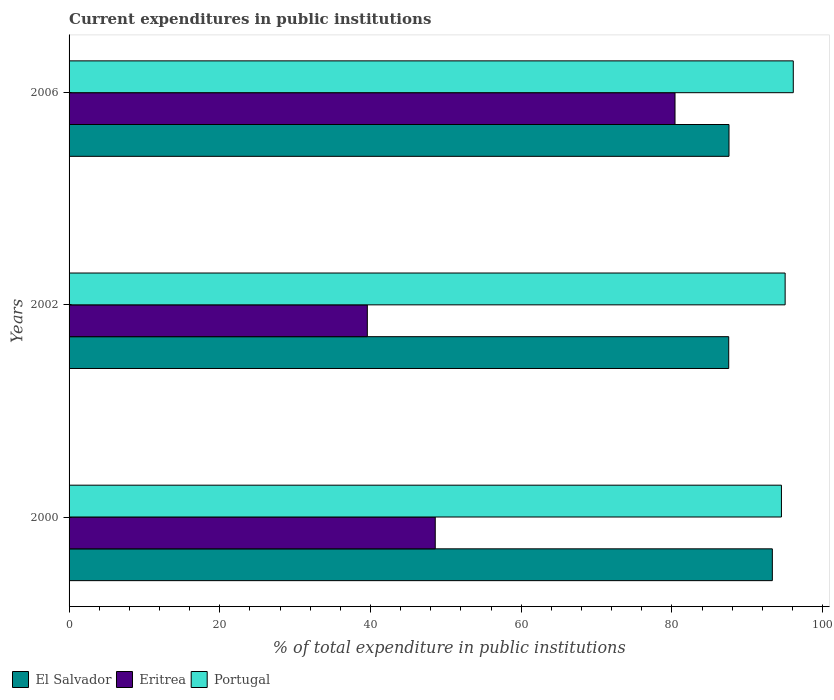How many different coloured bars are there?
Offer a terse response. 3. How many groups of bars are there?
Your answer should be very brief. 3. Are the number of bars per tick equal to the number of legend labels?
Offer a very short reply. Yes. How many bars are there on the 1st tick from the top?
Ensure brevity in your answer.  3. How many bars are there on the 1st tick from the bottom?
Your answer should be compact. 3. In how many cases, is the number of bars for a given year not equal to the number of legend labels?
Provide a succinct answer. 0. What is the current expenditures in public institutions in Eritrea in 2000?
Give a very brief answer. 48.59. Across all years, what is the maximum current expenditures in public institutions in El Salvador?
Your response must be concise. 93.33. Across all years, what is the minimum current expenditures in public institutions in El Salvador?
Offer a terse response. 87.54. In which year was the current expenditures in public institutions in El Salvador minimum?
Provide a short and direct response. 2002. What is the total current expenditures in public institutions in Eritrea in the graph?
Your answer should be compact. 168.59. What is the difference between the current expenditures in public institutions in Portugal in 2000 and that in 2006?
Provide a succinct answer. -1.57. What is the difference between the current expenditures in public institutions in Portugal in 2006 and the current expenditures in public institutions in El Salvador in 2000?
Give a very brief answer. 2.78. What is the average current expenditures in public institutions in Portugal per year?
Provide a short and direct response. 95.22. In the year 2002, what is the difference between the current expenditures in public institutions in Eritrea and current expenditures in public institutions in Portugal?
Provide a short and direct response. -55.45. What is the ratio of the current expenditures in public institutions in El Salvador in 2000 to that in 2006?
Ensure brevity in your answer.  1.07. Is the current expenditures in public institutions in El Salvador in 2000 less than that in 2006?
Give a very brief answer. No. Is the difference between the current expenditures in public institutions in Eritrea in 2002 and 2006 greater than the difference between the current expenditures in public institutions in Portugal in 2002 and 2006?
Your answer should be very brief. No. What is the difference between the highest and the second highest current expenditures in public institutions in El Salvador?
Provide a short and direct response. 5.75. What is the difference between the highest and the lowest current expenditures in public institutions in Portugal?
Make the answer very short. 1.57. In how many years, is the current expenditures in public institutions in Eritrea greater than the average current expenditures in public institutions in Eritrea taken over all years?
Keep it short and to the point. 1. Is the sum of the current expenditures in public institutions in Eritrea in 2000 and 2002 greater than the maximum current expenditures in public institutions in Portugal across all years?
Your response must be concise. No. What does the 2nd bar from the bottom in 2000 represents?
Provide a short and direct response. Eritrea. Is it the case that in every year, the sum of the current expenditures in public institutions in El Salvador and current expenditures in public institutions in Portugal is greater than the current expenditures in public institutions in Eritrea?
Give a very brief answer. Yes. Are all the bars in the graph horizontal?
Your answer should be compact. Yes. Does the graph contain any zero values?
Keep it short and to the point. No. Does the graph contain grids?
Offer a terse response. No. Where does the legend appear in the graph?
Offer a very short reply. Bottom left. How are the legend labels stacked?
Your answer should be compact. Horizontal. What is the title of the graph?
Keep it short and to the point. Current expenditures in public institutions. What is the label or title of the X-axis?
Offer a very short reply. % of total expenditure in public institutions. What is the label or title of the Y-axis?
Ensure brevity in your answer.  Years. What is the % of total expenditure in public institutions of El Salvador in 2000?
Provide a short and direct response. 93.33. What is the % of total expenditure in public institutions in Eritrea in 2000?
Provide a short and direct response. 48.59. What is the % of total expenditure in public institutions of Portugal in 2000?
Provide a succinct answer. 94.54. What is the % of total expenditure in public institutions in El Salvador in 2002?
Offer a terse response. 87.54. What is the % of total expenditure in public institutions in Eritrea in 2002?
Your answer should be compact. 39.58. What is the % of total expenditure in public institutions in Portugal in 2002?
Provide a short and direct response. 95.03. What is the % of total expenditure in public institutions in El Salvador in 2006?
Give a very brief answer. 87.58. What is the % of total expenditure in public institutions in Eritrea in 2006?
Provide a succinct answer. 80.41. What is the % of total expenditure in public institutions of Portugal in 2006?
Your response must be concise. 96.11. Across all years, what is the maximum % of total expenditure in public institutions of El Salvador?
Provide a succinct answer. 93.33. Across all years, what is the maximum % of total expenditure in public institutions in Eritrea?
Your answer should be compact. 80.41. Across all years, what is the maximum % of total expenditure in public institutions of Portugal?
Your answer should be compact. 96.11. Across all years, what is the minimum % of total expenditure in public institutions in El Salvador?
Give a very brief answer. 87.54. Across all years, what is the minimum % of total expenditure in public institutions of Eritrea?
Ensure brevity in your answer.  39.58. Across all years, what is the minimum % of total expenditure in public institutions of Portugal?
Offer a terse response. 94.54. What is the total % of total expenditure in public institutions of El Salvador in the graph?
Your answer should be compact. 268.45. What is the total % of total expenditure in public institutions in Eritrea in the graph?
Ensure brevity in your answer.  168.59. What is the total % of total expenditure in public institutions of Portugal in the graph?
Give a very brief answer. 285.67. What is the difference between the % of total expenditure in public institutions in El Salvador in 2000 and that in 2002?
Make the answer very short. 5.79. What is the difference between the % of total expenditure in public institutions in Eritrea in 2000 and that in 2002?
Your response must be concise. 9.01. What is the difference between the % of total expenditure in public institutions in Portugal in 2000 and that in 2002?
Give a very brief answer. -0.49. What is the difference between the % of total expenditure in public institutions in El Salvador in 2000 and that in 2006?
Provide a succinct answer. 5.75. What is the difference between the % of total expenditure in public institutions in Eritrea in 2000 and that in 2006?
Ensure brevity in your answer.  -31.82. What is the difference between the % of total expenditure in public institutions in Portugal in 2000 and that in 2006?
Provide a short and direct response. -1.57. What is the difference between the % of total expenditure in public institutions of El Salvador in 2002 and that in 2006?
Give a very brief answer. -0.04. What is the difference between the % of total expenditure in public institutions in Eritrea in 2002 and that in 2006?
Offer a terse response. -40.83. What is the difference between the % of total expenditure in public institutions in Portugal in 2002 and that in 2006?
Give a very brief answer. -1.08. What is the difference between the % of total expenditure in public institutions of El Salvador in 2000 and the % of total expenditure in public institutions of Eritrea in 2002?
Your response must be concise. 53.75. What is the difference between the % of total expenditure in public institutions of El Salvador in 2000 and the % of total expenditure in public institutions of Portugal in 2002?
Make the answer very short. -1.7. What is the difference between the % of total expenditure in public institutions of Eritrea in 2000 and the % of total expenditure in public institutions of Portugal in 2002?
Your answer should be very brief. -46.43. What is the difference between the % of total expenditure in public institutions of El Salvador in 2000 and the % of total expenditure in public institutions of Eritrea in 2006?
Offer a terse response. 12.92. What is the difference between the % of total expenditure in public institutions in El Salvador in 2000 and the % of total expenditure in public institutions in Portugal in 2006?
Ensure brevity in your answer.  -2.78. What is the difference between the % of total expenditure in public institutions in Eritrea in 2000 and the % of total expenditure in public institutions in Portugal in 2006?
Provide a succinct answer. -47.51. What is the difference between the % of total expenditure in public institutions of El Salvador in 2002 and the % of total expenditure in public institutions of Eritrea in 2006?
Your answer should be very brief. 7.13. What is the difference between the % of total expenditure in public institutions of El Salvador in 2002 and the % of total expenditure in public institutions of Portugal in 2006?
Your response must be concise. -8.57. What is the difference between the % of total expenditure in public institutions in Eritrea in 2002 and the % of total expenditure in public institutions in Portugal in 2006?
Provide a succinct answer. -56.53. What is the average % of total expenditure in public institutions in El Salvador per year?
Ensure brevity in your answer.  89.48. What is the average % of total expenditure in public institutions of Eritrea per year?
Your answer should be compact. 56.2. What is the average % of total expenditure in public institutions in Portugal per year?
Keep it short and to the point. 95.22. In the year 2000, what is the difference between the % of total expenditure in public institutions of El Salvador and % of total expenditure in public institutions of Eritrea?
Keep it short and to the point. 44.74. In the year 2000, what is the difference between the % of total expenditure in public institutions in El Salvador and % of total expenditure in public institutions in Portugal?
Your response must be concise. -1.21. In the year 2000, what is the difference between the % of total expenditure in public institutions in Eritrea and % of total expenditure in public institutions in Portugal?
Your answer should be very brief. -45.94. In the year 2002, what is the difference between the % of total expenditure in public institutions of El Salvador and % of total expenditure in public institutions of Eritrea?
Give a very brief answer. 47.96. In the year 2002, what is the difference between the % of total expenditure in public institutions in El Salvador and % of total expenditure in public institutions in Portugal?
Make the answer very short. -7.49. In the year 2002, what is the difference between the % of total expenditure in public institutions of Eritrea and % of total expenditure in public institutions of Portugal?
Provide a short and direct response. -55.45. In the year 2006, what is the difference between the % of total expenditure in public institutions of El Salvador and % of total expenditure in public institutions of Eritrea?
Provide a succinct answer. 7.16. In the year 2006, what is the difference between the % of total expenditure in public institutions in El Salvador and % of total expenditure in public institutions in Portugal?
Ensure brevity in your answer.  -8.53. In the year 2006, what is the difference between the % of total expenditure in public institutions of Eritrea and % of total expenditure in public institutions of Portugal?
Provide a short and direct response. -15.7. What is the ratio of the % of total expenditure in public institutions in El Salvador in 2000 to that in 2002?
Make the answer very short. 1.07. What is the ratio of the % of total expenditure in public institutions of Eritrea in 2000 to that in 2002?
Your answer should be compact. 1.23. What is the ratio of the % of total expenditure in public institutions of El Salvador in 2000 to that in 2006?
Your answer should be compact. 1.07. What is the ratio of the % of total expenditure in public institutions in Eritrea in 2000 to that in 2006?
Provide a short and direct response. 0.6. What is the ratio of the % of total expenditure in public institutions of Portugal in 2000 to that in 2006?
Your answer should be compact. 0.98. What is the ratio of the % of total expenditure in public institutions in El Salvador in 2002 to that in 2006?
Offer a very short reply. 1. What is the ratio of the % of total expenditure in public institutions of Eritrea in 2002 to that in 2006?
Offer a terse response. 0.49. What is the ratio of the % of total expenditure in public institutions in Portugal in 2002 to that in 2006?
Offer a very short reply. 0.99. What is the difference between the highest and the second highest % of total expenditure in public institutions of El Salvador?
Your answer should be very brief. 5.75. What is the difference between the highest and the second highest % of total expenditure in public institutions of Eritrea?
Your answer should be compact. 31.82. What is the difference between the highest and the second highest % of total expenditure in public institutions of Portugal?
Make the answer very short. 1.08. What is the difference between the highest and the lowest % of total expenditure in public institutions of El Salvador?
Your answer should be very brief. 5.79. What is the difference between the highest and the lowest % of total expenditure in public institutions in Eritrea?
Ensure brevity in your answer.  40.83. What is the difference between the highest and the lowest % of total expenditure in public institutions in Portugal?
Provide a short and direct response. 1.57. 